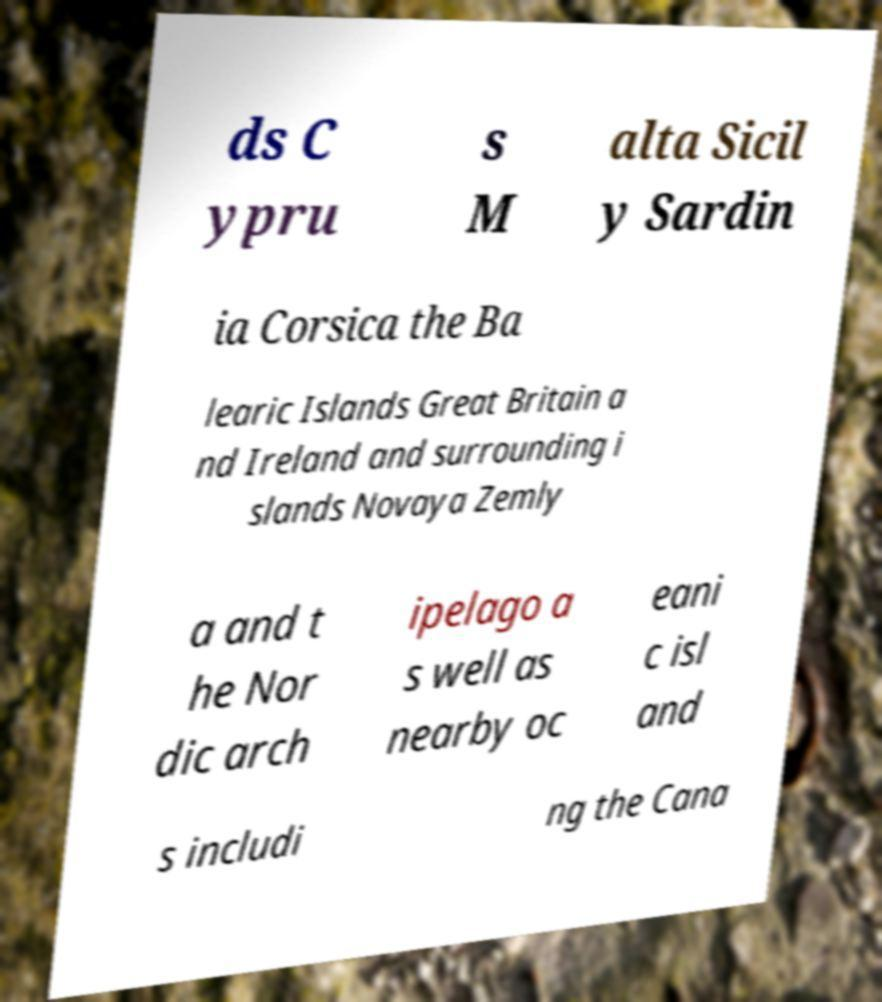Could you extract and type out the text from this image? ds C ypru s M alta Sicil y Sardin ia Corsica the Ba learic Islands Great Britain a nd Ireland and surrounding i slands Novaya Zemly a and t he Nor dic arch ipelago a s well as nearby oc eani c isl and s includi ng the Cana 